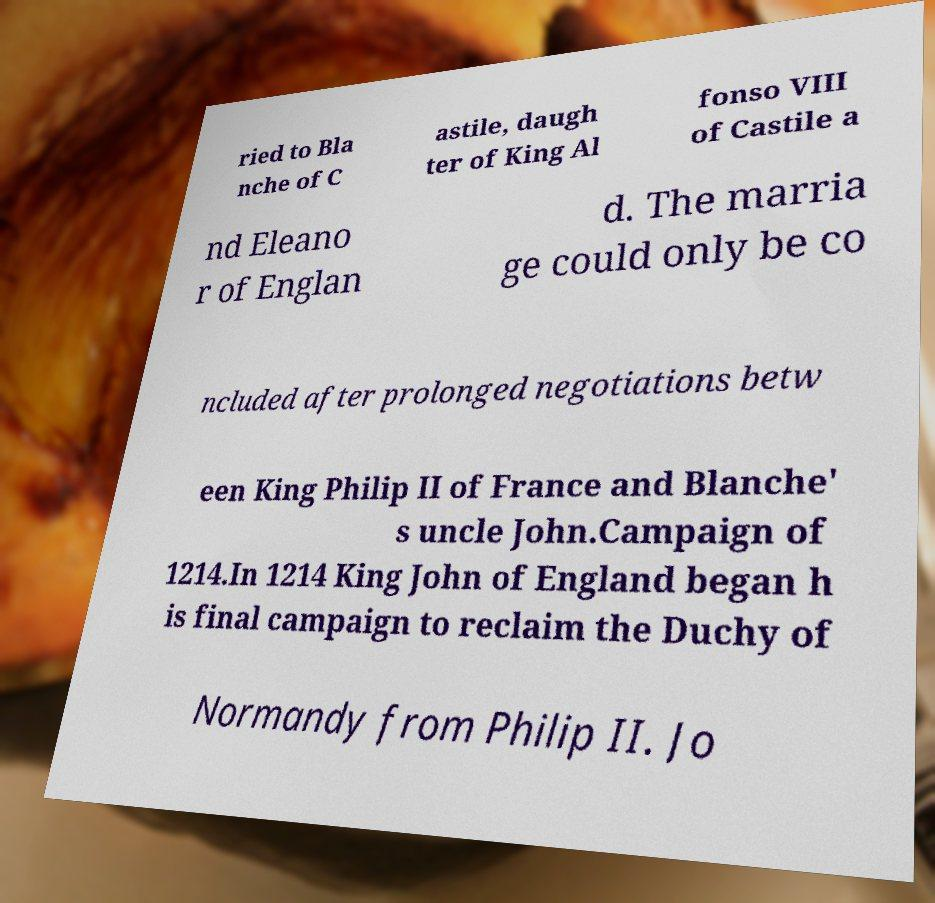I need the written content from this picture converted into text. Can you do that? ried to Bla nche of C astile, daugh ter of King Al fonso VIII of Castile a nd Eleano r of Englan d. The marria ge could only be co ncluded after prolonged negotiations betw een King Philip II of France and Blanche' s uncle John.Campaign of 1214.In 1214 King John of England began h is final campaign to reclaim the Duchy of Normandy from Philip II. Jo 